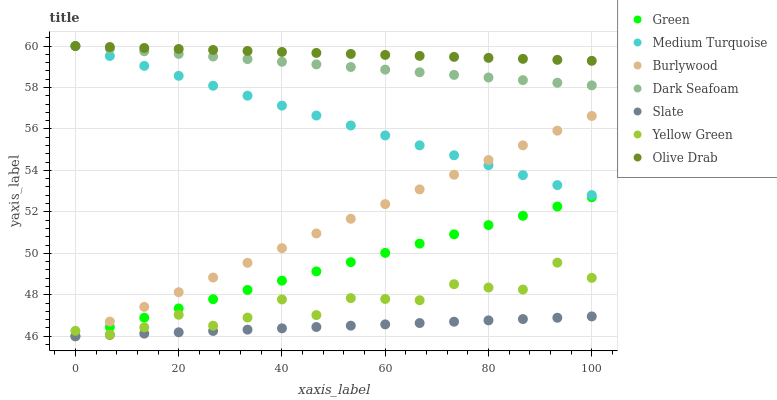Does Slate have the minimum area under the curve?
Answer yes or no. Yes. Does Olive Drab have the maximum area under the curve?
Answer yes or no. Yes. Does Burlywood have the minimum area under the curve?
Answer yes or no. No. Does Burlywood have the maximum area under the curve?
Answer yes or no. No. Is Medium Turquoise the smoothest?
Answer yes or no. Yes. Is Yellow Green the roughest?
Answer yes or no. Yes. Is Burlywood the smoothest?
Answer yes or no. No. Is Burlywood the roughest?
Answer yes or no. No. Does Burlywood have the lowest value?
Answer yes or no. Yes. Does Dark Seafoam have the lowest value?
Answer yes or no. No. Does Olive Drab have the highest value?
Answer yes or no. Yes. Does Burlywood have the highest value?
Answer yes or no. No. Is Green less than Olive Drab?
Answer yes or no. Yes. Is Yellow Green greater than Slate?
Answer yes or no. Yes. Does Slate intersect Green?
Answer yes or no. Yes. Is Slate less than Green?
Answer yes or no. No. Is Slate greater than Green?
Answer yes or no. No. Does Green intersect Olive Drab?
Answer yes or no. No. 